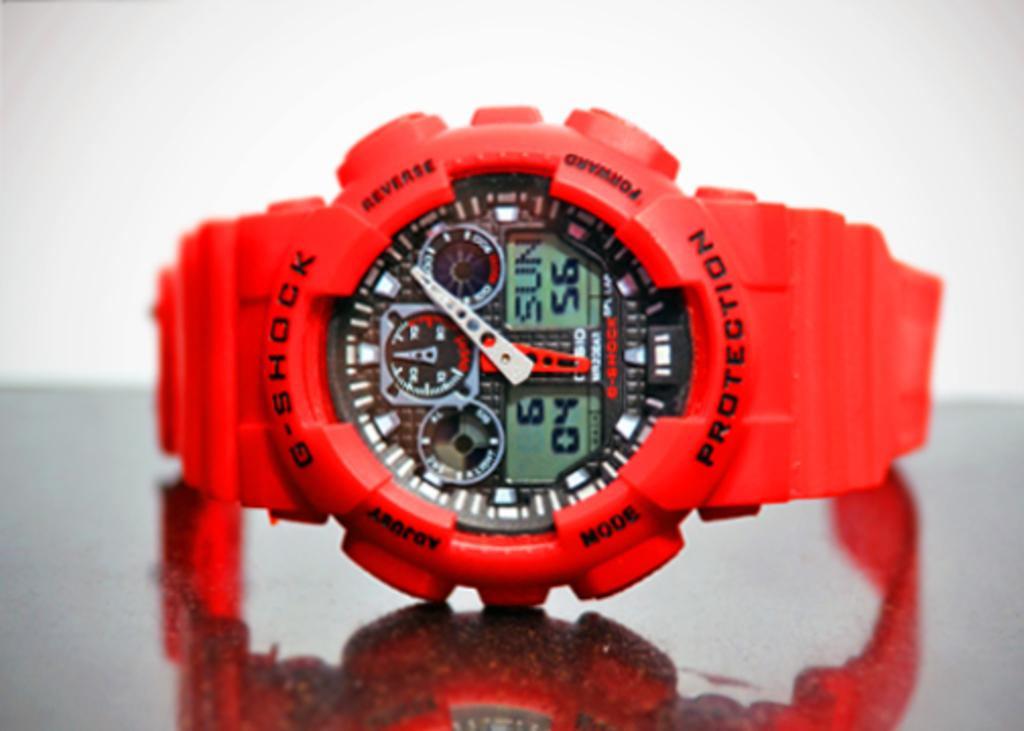<image>
Write a terse but informative summary of the picture. Red wristtwatch that says "G-shock protection" on it. 